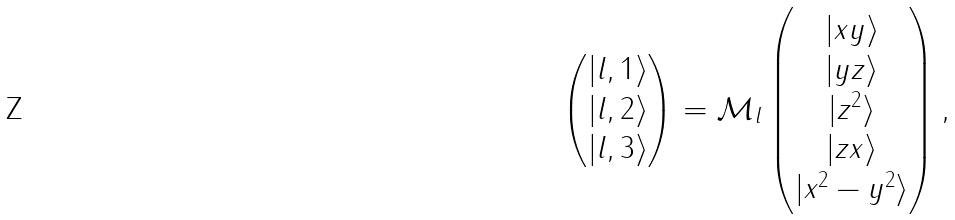Convert formula to latex. <formula><loc_0><loc_0><loc_500><loc_500>\begin{pmatrix} | l , 1 \rangle \\ | l , 2 \rangle \\ | l , 3 \rangle \\ \end{pmatrix} = \mathcal { M } _ { l } \begin{pmatrix} | x y \rangle \\ | y z \rangle \\ | z ^ { 2 } \rangle \\ | z x \rangle \\ | x ^ { 2 } - y ^ { 2 } \rangle \end{pmatrix} ,</formula> 